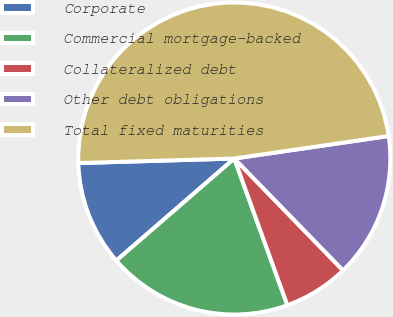<chart> <loc_0><loc_0><loc_500><loc_500><pie_chart><fcel>Corporate<fcel>Commercial mortgage-backed<fcel>Collateralized debt<fcel>Other debt obligations<fcel>Total fixed maturities<nl><fcel>10.89%<fcel>19.17%<fcel>6.75%<fcel>15.03%<fcel>48.16%<nl></chart> 